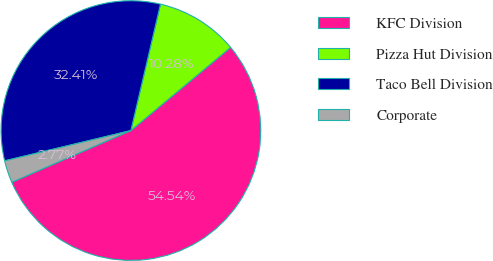Convert chart to OTSL. <chart><loc_0><loc_0><loc_500><loc_500><pie_chart><fcel>KFC Division<fcel>Pizza Hut Division<fcel>Taco Bell Division<fcel>Corporate<nl><fcel>54.55%<fcel>10.28%<fcel>32.41%<fcel>2.77%<nl></chart> 